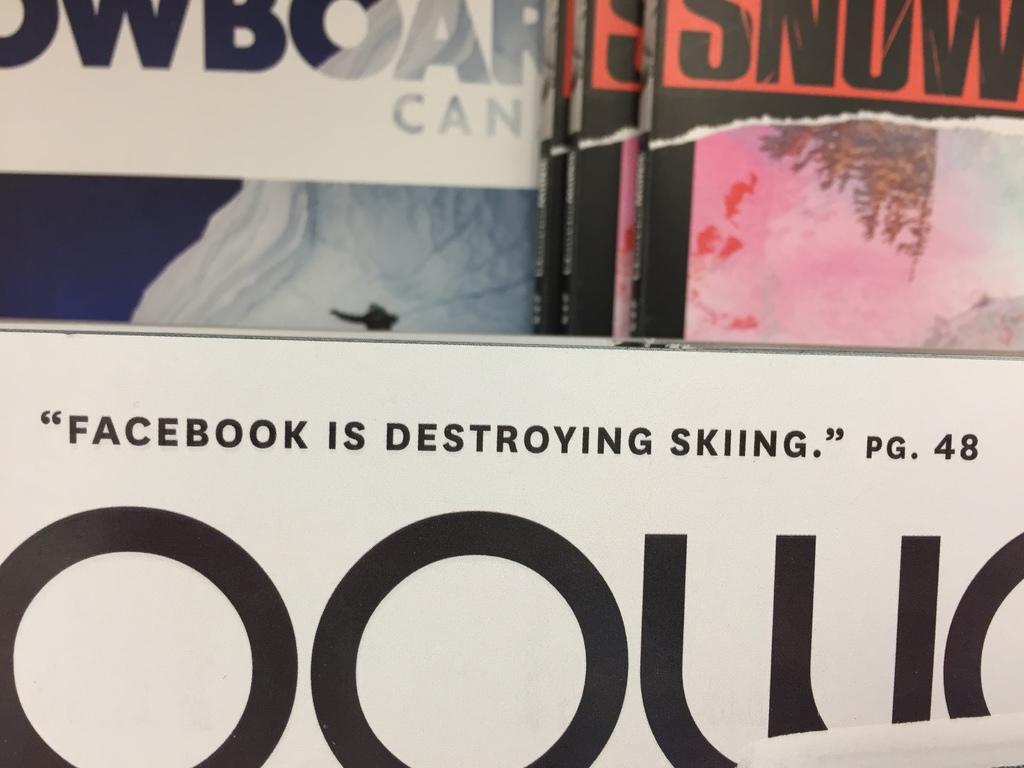<image>
Present a compact description of the photo's key features. A quote which states that Facebook is destroying skiing. 